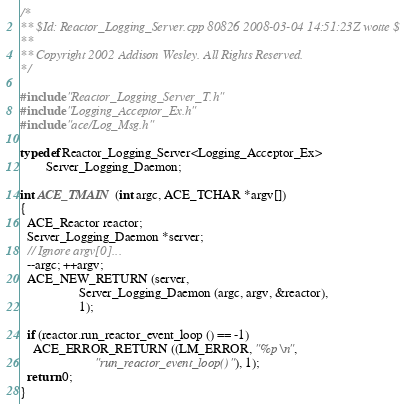<code> <loc_0><loc_0><loc_500><loc_500><_C++_>/*
** $Id: Reactor_Logging_Server.cpp 80826 2008-03-04 14:51:23Z wotte $
**
** Copyright 2002 Addison Wesley. All Rights Reserved.
*/

#include "Reactor_Logging_Server_T.h"
#include "Logging_Acceptor_Ex.h"
#include "ace/Log_Msg.h"

typedef Reactor_Logging_Server<Logging_Acceptor_Ex>
        Server_Logging_Daemon;

int ACE_TMAIN (int argc, ACE_TCHAR *argv[])
{
  ACE_Reactor reactor;
  Server_Logging_Daemon *server;
  // Ignore argv[0]...
  --argc; ++argv;
  ACE_NEW_RETURN (server,
                  Server_Logging_Daemon (argc, argv, &reactor),
                  1);

  if (reactor.run_reactor_event_loop () == -1)
    ACE_ERROR_RETURN ((LM_ERROR, "%p\n",
                       "run_reactor_event_loop()"), 1);
  return 0;
}

</code> 